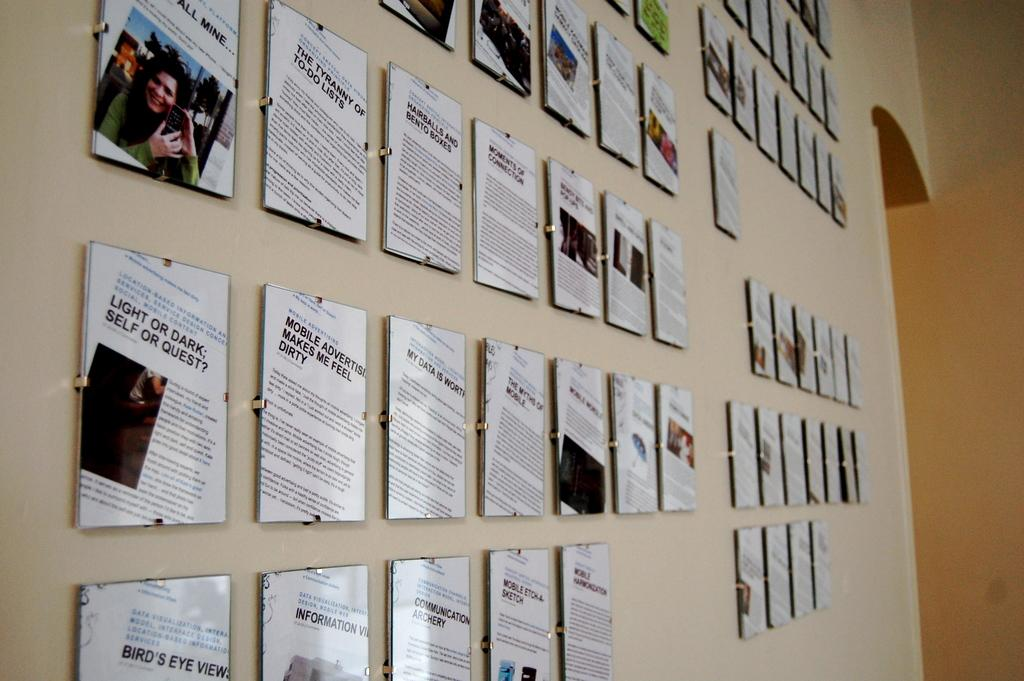<image>
Summarize the visual content of the image. The wall is full of prints of articles like "Mobile Etch-A-Sketch" and Light or Dark; Self or Quest?" 